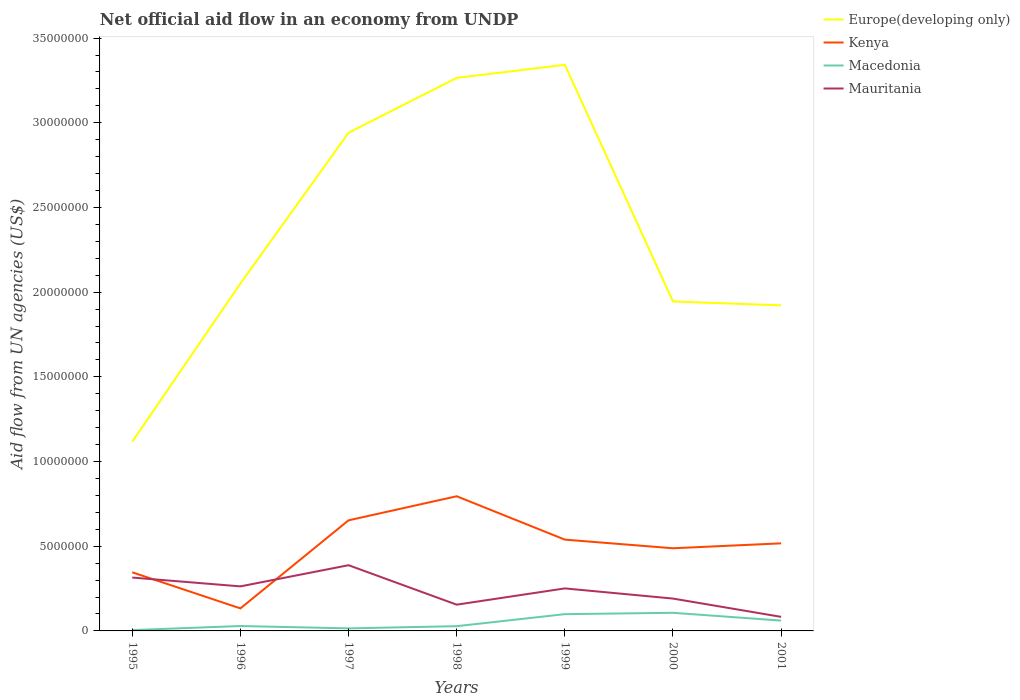How many different coloured lines are there?
Offer a terse response. 4. Does the line corresponding to Kenya intersect with the line corresponding to Europe(developing only)?
Keep it short and to the point. No. Is the number of lines equal to the number of legend labels?
Ensure brevity in your answer.  Yes. Across all years, what is the maximum net official aid flow in Mauritania?
Give a very brief answer. 8.30e+05. What is the total net official aid flow in Macedonia in the graph?
Provide a succinct answer. -2.40e+05. What is the difference between the highest and the second highest net official aid flow in Europe(developing only)?
Make the answer very short. 2.22e+07. What is the difference between the highest and the lowest net official aid flow in Macedonia?
Offer a very short reply. 3. Is the net official aid flow in Macedonia strictly greater than the net official aid flow in Mauritania over the years?
Offer a terse response. Yes. How many lines are there?
Keep it short and to the point. 4. What is the difference between two consecutive major ticks on the Y-axis?
Your answer should be very brief. 5.00e+06. How many legend labels are there?
Your answer should be very brief. 4. How are the legend labels stacked?
Provide a short and direct response. Vertical. What is the title of the graph?
Make the answer very short. Net official aid flow in an economy from UNDP. Does "Denmark" appear as one of the legend labels in the graph?
Make the answer very short. No. What is the label or title of the X-axis?
Your answer should be compact. Years. What is the label or title of the Y-axis?
Ensure brevity in your answer.  Aid flow from UN agencies (US$). What is the Aid flow from UN agencies (US$) in Europe(developing only) in 1995?
Your answer should be compact. 1.12e+07. What is the Aid flow from UN agencies (US$) of Kenya in 1995?
Offer a very short reply. 3.46e+06. What is the Aid flow from UN agencies (US$) in Mauritania in 1995?
Provide a succinct answer. 3.15e+06. What is the Aid flow from UN agencies (US$) of Europe(developing only) in 1996?
Give a very brief answer. 2.05e+07. What is the Aid flow from UN agencies (US$) in Kenya in 1996?
Give a very brief answer. 1.33e+06. What is the Aid flow from UN agencies (US$) in Macedonia in 1996?
Provide a short and direct response. 2.90e+05. What is the Aid flow from UN agencies (US$) in Mauritania in 1996?
Provide a succinct answer. 2.63e+06. What is the Aid flow from UN agencies (US$) of Europe(developing only) in 1997?
Your answer should be very brief. 2.94e+07. What is the Aid flow from UN agencies (US$) of Kenya in 1997?
Your answer should be compact. 6.53e+06. What is the Aid flow from UN agencies (US$) of Mauritania in 1997?
Provide a succinct answer. 3.88e+06. What is the Aid flow from UN agencies (US$) of Europe(developing only) in 1998?
Provide a short and direct response. 3.26e+07. What is the Aid flow from UN agencies (US$) in Kenya in 1998?
Provide a succinct answer. 7.95e+06. What is the Aid flow from UN agencies (US$) of Mauritania in 1998?
Keep it short and to the point. 1.55e+06. What is the Aid flow from UN agencies (US$) in Europe(developing only) in 1999?
Make the answer very short. 3.34e+07. What is the Aid flow from UN agencies (US$) in Kenya in 1999?
Provide a short and direct response. 5.39e+06. What is the Aid flow from UN agencies (US$) in Macedonia in 1999?
Offer a very short reply. 9.90e+05. What is the Aid flow from UN agencies (US$) of Mauritania in 1999?
Provide a short and direct response. 2.51e+06. What is the Aid flow from UN agencies (US$) of Europe(developing only) in 2000?
Give a very brief answer. 1.94e+07. What is the Aid flow from UN agencies (US$) in Kenya in 2000?
Make the answer very short. 4.88e+06. What is the Aid flow from UN agencies (US$) of Macedonia in 2000?
Your response must be concise. 1.07e+06. What is the Aid flow from UN agencies (US$) in Mauritania in 2000?
Your answer should be compact. 1.91e+06. What is the Aid flow from UN agencies (US$) in Europe(developing only) in 2001?
Your response must be concise. 1.92e+07. What is the Aid flow from UN agencies (US$) in Kenya in 2001?
Give a very brief answer. 5.17e+06. What is the Aid flow from UN agencies (US$) of Macedonia in 2001?
Provide a short and direct response. 6.10e+05. What is the Aid flow from UN agencies (US$) of Mauritania in 2001?
Your answer should be very brief. 8.30e+05. Across all years, what is the maximum Aid flow from UN agencies (US$) of Europe(developing only)?
Offer a very short reply. 3.34e+07. Across all years, what is the maximum Aid flow from UN agencies (US$) in Kenya?
Your response must be concise. 7.95e+06. Across all years, what is the maximum Aid flow from UN agencies (US$) in Macedonia?
Provide a short and direct response. 1.07e+06. Across all years, what is the maximum Aid flow from UN agencies (US$) of Mauritania?
Provide a short and direct response. 3.88e+06. Across all years, what is the minimum Aid flow from UN agencies (US$) of Europe(developing only)?
Offer a very short reply. 1.12e+07. Across all years, what is the minimum Aid flow from UN agencies (US$) of Kenya?
Give a very brief answer. 1.33e+06. Across all years, what is the minimum Aid flow from UN agencies (US$) of Macedonia?
Offer a terse response. 5.00e+04. Across all years, what is the minimum Aid flow from UN agencies (US$) in Mauritania?
Provide a short and direct response. 8.30e+05. What is the total Aid flow from UN agencies (US$) of Europe(developing only) in the graph?
Offer a terse response. 1.66e+08. What is the total Aid flow from UN agencies (US$) of Kenya in the graph?
Your answer should be very brief. 3.47e+07. What is the total Aid flow from UN agencies (US$) of Macedonia in the graph?
Offer a terse response. 3.44e+06. What is the total Aid flow from UN agencies (US$) in Mauritania in the graph?
Offer a terse response. 1.65e+07. What is the difference between the Aid flow from UN agencies (US$) of Europe(developing only) in 1995 and that in 1996?
Offer a very short reply. -9.34e+06. What is the difference between the Aid flow from UN agencies (US$) in Kenya in 1995 and that in 1996?
Your answer should be compact. 2.13e+06. What is the difference between the Aid flow from UN agencies (US$) in Mauritania in 1995 and that in 1996?
Provide a short and direct response. 5.20e+05. What is the difference between the Aid flow from UN agencies (US$) in Europe(developing only) in 1995 and that in 1997?
Ensure brevity in your answer.  -1.82e+07. What is the difference between the Aid flow from UN agencies (US$) in Kenya in 1995 and that in 1997?
Your response must be concise. -3.07e+06. What is the difference between the Aid flow from UN agencies (US$) of Macedonia in 1995 and that in 1997?
Ensure brevity in your answer.  -1.00e+05. What is the difference between the Aid flow from UN agencies (US$) in Mauritania in 1995 and that in 1997?
Offer a very short reply. -7.30e+05. What is the difference between the Aid flow from UN agencies (US$) in Europe(developing only) in 1995 and that in 1998?
Make the answer very short. -2.15e+07. What is the difference between the Aid flow from UN agencies (US$) of Kenya in 1995 and that in 1998?
Provide a short and direct response. -4.49e+06. What is the difference between the Aid flow from UN agencies (US$) of Macedonia in 1995 and that in 1998?
Provide a succinct answer. -2.30e+05. What is the difference between the Aid flow from UN agencies (US$) in Mauritania in 1995 and that in 1998?
Ensure brevity in your answer.  1.60e+06. What is the difference between the Aid flow from UN agencies (US$) of Europe(developing only) in 1995 and that in 1999?
Your response must be concise. -2.22e+07. What is the difference between the Aid flow from UN agencies (US$) of Kenya in 1995 and that in 1999?
Provide a succinct answer. -1.93e+06. What is the difference between the Aid flow from UN agencies (US$) of Macedonia in 1995 and that in 1999?
Provide a succinct answer. -9.40e+05. What is the difference between the Aid flow from UN agencies (US$) of Mauritania in 1995 and that in 1999?
Offer a very short reply. 6.40e+05. What is the difference between the Aid flow from UN agencies (US$) in Europe(developing only) in 1995 and that in 2000?
Your response must be concise. -8.28e+06. What is the difference between the Aid flow from UN agencies (US$) of Kenya in 1995 and that in 2000?
Make the answer very short. -1.42e+06. What is the difference between the Aid flow from UN agencies (US$) of Macedonia in 1995 and that in 2000?
Give a very brief answer. -1.02e+06. What is the difference between the Aid flow from UN agencies (US$) in Mauritania in 1995 and that in 2000?
Offer a terse response. 1.24e+06. What is the difference between the Aid flow from UN agencies (US$) of Europe(developing only) in 1995 and that in 2001?
Provide a succinct answer. -8.05e+06. What is the difference between the Aid flow from UN agencies (US$) of Kenya in 1995 and that in 2001?
Keep it short and to the point. -1.71e+06. What is the difference between the Aid flow from UN agencies (US$) of Macedonia in 1995 and that in 2001?
Provide a short and direct response. -5.60e+05. What is the difference between the Aid flow from UN agencies (US$) of Mauritania in 1995 and that in 2001?
Ensure brevity in your answer.  2.32e+06. What is the difference between the Aid flow from UN agencies (US$) in Europe(developing only) in 1996 and that in 1997?
Give a very brief answer. -8.90e+06. What is the difference between the Aid flow from UN agencies (US$) in Kenya in 1996 and that in 1997?
Your response must be concise. -5.20e+06. What is the difference between the Aid flow from UN agencies (US$) of Macedonia in 1996 and that in 1997?
Offer a terse response. 1.40e+05. What is the difference between the Aid flow from UN agencies (US$) in Mauritania in 1996 and that in 1997?
Your response must be concise. -1.25e+06. What is the difference between the Aid flow from UN agencies (US$) of Europe(developing only) in 1996 and that in 1998?
Your response must be concise. -1.21e+07. What is the difference between the Aid flow from UN agencies (US$) of Kenya in 1996 and that in 1998?
Give a very brief answer. -6.62e+06. What is the difference between the Aid flow from UN agencies (US$) of Macedonia in 1996 and that in 1998?
Ensure brevity in your answer.  10000. What is the difference between the Aid flow from UN agencies (US$) of Mauritania in 1996 and that in 1998?
Offer a terse response. 1.08e+06. What is the difference between the Aid flow from UN agencies (US$) in Europe(developing only) in 1996 and that in 1999?
Your response must be concise. -1.29e+07. What is the difference between the Aid flow from UN agencies (US$) in Kenya in 1996 and that in 1999?
Your answer should be compact. -4.06e+06. What is the difference between the Aid flow from UN agencies (US$) in Macedonia in 1996 and that in 1999?
Give a very brief answer. -7.00e+05. What is the difference between the Aid flow from UN agencies (US$) of Europe(developing only) in 1996 and that in 2000?
Keep it short and to the point. 1.06e+06. What is the difference between the Aid flow from UN agencies (US$) in Kenya in 1996 and that in 2000?
Keep it short and to the point. -3.55e+06. What is the difference between the Aid flow from UN agencies (US$) in Macedonia in 1996 and that in 2000?
Offer a very short reply. -7.80e+05. What is the difference between the Aid flow from UN agencies (US$) of Mauritania in 1996 and that in 2000?
Keep it short and to the point. 7.20e+05. What is the difference between the Aid flow from UN agencies (US$) in Europe(developing only) in 1996 and that in 2001?
Offer a very short reply. 1.29e+06. What is the difference between the Aid flow from UN agencies (US$) in Kenya in 1996 and that in 2001?
Offer a very short reply. -3.84e+06. What is the difference between the Aid flow from UN agencies (US$) of Macedonia in 1996 and that in 2001?
Make the answer very short. -3.20e+05. What is the difference between the Aid flow from UN agencies (US$) in Mauritania in 1996 and that in 2001?
Keep it short and to the point. 1.80e+06. What is the difference between the Aid flow from UN agencies (US$) of Europe(developing only) in 1997 and that in 1998?
Give a very brief answer. -3.24e+06. What is the difference between the Aid flow from UN agencies (US$) of Kenya in 1997 and that in 1998?
Keep it short and to the point. -1.42e+06. What is the difference between the Aid flow from UN agencies (US$) of Mauritania in 1997 and that in 1998?
Your answer should be very brief. 2.33e+06. What is the difference between the Aid flow from UN agencies (US$) of Europe(developing only) in 1997 and that in 1999?
Your response must be concise. -4.01e+06. What is the difference between the Aid flow from UN agencies (US$) of Kenya in 1997 and that in 1999?
Provide a succinct answer. 1.14e+06. What is the difference between the Aid flow from UN agencies (US$) of Macedonia in 1997 and that in 1999?
Provide a succinct answer. -8.40e+05. What is the difference between the Aid flow from UN agencies (US$) of Mauritania in 1997 and that in 1999?
Ensure brevity in your answer.  1.37e+06. What is the difference between the Aid flow from UN agencies (US$) of Europe(developing only) in 1997 and that in 2000?
Your response must be concise. 9.96e+06. What is the difference between the Aid flow from UN agencies (US$) of Kenya in 1997 and that in 2000?
Make the answer very short. 1.65e+06. What is the difference between the Aid flow from UN agencies (US$) of Macedonia in 1997 and that in 2000?
Provide a short and direct response. -9.20e+05. What is the difference between the Aid flow from UN agencies (US$) of Mauritania in 1997 and that in 2000?
Your answer should be compact. 1.97e+06. What is the difference between the Aid flow from UN agencies (US$) in Europe(developing only) in 1997 and that in 2001?
Your response must be concise. 1.02e+07. What is the difference between the Aid flow from UN agencies (US$) of Kenya in 1997 and that in 2001?
Your response must be concise. 1.36e+06. What is the difference between the Aid flow from UN agencies (US$) in Macedonia in 1997 and that in 2001?
Your response must be concise. -4.60e+05. What is the difference between the Aid flow from UN agencies (US$) in Mauritania in 1997 and that in 2001?
Offer a very short reply. 3.05e+06. What is the difference between the Aid flow from UN agencies (US$) of Europe(developing only) in 1998 and that in 1999?
Offer a terse response. -7.70e+05. What is the difference between the Aid flow from UN agencies (US$) in Kenya in 1998 and that in 1999?
Your answer should be compact. 2.56e+06. What is the difference between the Aid flow from UN agencies (US$) of Macedonia in 1998 and that in 1999?
Keep it short and to the point. -7.10e+05. What is the difference between the Aid flow from UN agencies (US$) of Mauritania in 1998 and that in 1999?
Keep it short and to the point. -9.60e+05. What is the difference between the Aid flow from UN agencies (US$) in Europe(developing only) in 1998 and that in 2000?
Give a very brief answer. 1.32e+07. What is the difference between the Aid flow from UN agencies (US$) in Kenya in 1998 and that in 2000?
Offer a terse response. 3.07e+06. What is the difference between the Aid flow from UN agencies (US$) in Macedonia in 1998 and that in 2000?
Give a very brief answer. -7.90e+05. What is the difference between the Aid flow from UN agencies (US$) of Mauritania in 1998 and that in 2000?
Your answer should be compact. -3.60e+05. What is the difference between the Aid flow from UN agencies (US$) of Europe(developing only) in 1998 and that in 2001?
Provide a succinct answer. 1.34e+07. What is the difference between the Aid flow from UN agencies (US$) in Kenya in 1998 and that in 2001?
Give a very brief answer. 2.78e+06. What is the difference between the Aid flow from UN agencies (US$) in Macedonia in 1998 and that in 2001?
Give a very brief answer. -3.30e+05. What is the difference between the Aid flow from UN agencies (US$) of Mauritania in 1998 and that in 2001?
Make the answer very short. 7.20e+05. What is the difference between the Aid flow from UN agencies (US$) in Europe(developing only) in 1999 and that in 2000?
Offer a very short reply. 1.40e+07. What is the difference between the Aid flow from UN agencies (US$) in Kenya in 1999 and that in 2000?
Your answer should be very brief. 5.10e+05. What is the difference between the Aid flow from UN agencies (US$) of Macedonia in 1999 and that in 2000?
Your answer should be very brief. -8.00e+04. What is the difference between the Aid flow from UN agencies (US$) in Mauritania in 1999 and that in 2000?
Your answer should be very brief. 6.00e+05. What is the difference between the Aid flow from UN agencies (US$) of Europe(developing only) in 1999 and that in 2001?
Provide a short and direct response. 1.42e+07. What is the difference between the Aid flow from UN agencies (US$) in Kenya in 1999 and that in 2001?
Keep it short and to the point. 2.20e+05. What is the difference between the Aid flow from UN agencies (US$) in Mauritania in 1999 and that in 2001?
Make the answer very short. 1.68e+06. What is the difference between the Aid flow from UN agencies (US$) in Europe(developing only) in 2000 and that in 2001?
Provide a short and direct response. 2.30e+05. What is the difference between the Aid flow from UN agencies (US$) in Mauritania in 2000 and that in 2001?
Your response must be concise. 1.08e+06. What is the difference between the Aid flow from UN agencies (US$) in Europe(developing only) in 1995 and the Aid flow from UN agencies (US$) in Kenya in 1996?
Provide a succinct answer. 9.84e+06. What is the difference between the Aid flow from UN agencies (US$) in Europe(developing only) in 1995 and the Aid flow from UN agencies (US$) in Macedonia in 1996?
Offer a terse response. 1.09e+07. What is the difference between the Aid flow from UN agencies (US$) in Europe(developing only) in 1995 and the Aid flow from UN agencies (US$) in Mauritania in 1996?
Offer a terse response. 8.54e+06. What is the difference between the Aid flow from UN agencies (US$) of Kenya in 1995 and the Aid flow from UN agencies (US$) of Macedonia in 1996?
Your answer should be very brief. 3.17e+06. What is the difference between the Aid flow from UN agencies (US$) in Kenya in 1995 and the Aid flow from UN agencies (US$) in Mauritania in 1996?
Give a very brief answer. 8.30e+05. What is the difference between the Aid flow from UN agencies (US$) in Macedonia in 1995 and the Aid flow from UN agencies (US$) in Mauritania in 1996?
Your response must be concise. -2.58e+06. What is the difference between the Aid flow from UN agencies (US$) of Europe(developing only) in 1995 and the Aid flow from UN agencies (US$) of Kenya in 1997?
Make the answer very short. 4.64e+06. What is the difference between the Aid flow from UN agencies (US$) in Europe(developing only) in 1995 and the Aid flow from UN agencies (US$) in Macedonia in 1997?
Your response must be concise. 1.10e+07. What is the difference between the Aid flow from UN agencies (US$) in Europe(developing only) in 1995 and the Aid flow from UN agencies (US$) in Mauritania in 1997?
Make the answer very short. 7.29e+06. What is the difference between the Aid flow from UN agencies (US$) in Kenya in 1995 and the Aid flow from UN agencies (US$) in Macedonia in 1997?
Make the answer very short. 3.31e+06. What is the difference between the Aid flow from UN agencies (US$) of Kenya in 1995 and the Aid flow from UN agencies (US$) of Mauritania in 1997?
Provide a short and direct response. -4.20e+05. What is the difference between the Aid flow from UN agencies (US$) of Macedonia in 1995 and the Aid flow from UN agencies (US$) of Mauritania in 1997?
Your response must be concise. -3.83e+06. What is the difference between the Aid flow from UN agencies (US$) of Europe(developing only) in 1995 and the Aid flow from UN agencies (US$) of Kenya in 1998?
Offer a terse response. 3.22e+06. What is the difference between the Aid flow from UN agencies (US$) in Europe(developing only) in 1995 and the Aid flow from UN agencies (US$) in Macedonia in 1998?
Keep it short and to the point. 1.09e+07. What is the difference between the Aid flow from UN agencies (US$) of Europe(developing only) in 1995 and the Aid flow from UN agencies (US$) of Mauritania in 1998?
Your answer should be very brief. 9.62e+06. What is the difference between the Aid flow from UN agencies (US$) of Kenya in 1995 and the Aid flow from UN agencies (US$) of Macedonia in 1998?
Your answer should be very brief. 3.18e+06. What is the difference between the Aid flow from UN agencies (US$) of Kenya in 1995 and the Aid flow from UN agencies (US$) of Mauritania in 1998?
Your response must be concise. 1.91e+06. What is the difference between the Aid flow from UN agencies (US$) in Macedonia in 1995 and the Aid flow from UN agencies (US$) in Mauritania in 1998?
Give a very brief answer. -1.50e+06. What is the difference between the Aid flow from UN agencies (US$) of Europe(developing only) in 1995 and the Aid flow from UN agencies (US$) of Kenya in 1999?
Offer a very short reply. 5.78e+06. What is the difference between the Aid flow from UN agencies (US$) of Europe(developing only) in 1995 and the Aid flow from UN agencies (US$) of Macedonia in 1999?
Your response must be concise. 1.02e+07. What is the difference between the Aid flow from UN agencies (US$) in Europe(developing only) in 1995 and the Aid flow from UN agencies (US$) in Mauritania in 1999?
Offer a terse response. 8.66e+06. What is the difference between the Aid flow from UN agencies (US$) in Kenya in 1995 and the Aid flow from UN agencies (US$) in Macedonia in 1999?
Give a very brief answer. 2.47e+06. What is the difference between the Aid flow from UN agencies (US$) in Kenya in 1995 and the Aid flow from UN agencies (US$) in Mauritania in 1999?
Offer a very short reply. 9.50e+05. What is the difference between the Aid flow from UN agencies (US$) in Macedonia in 1995 and the Aid flow from UN agencies (US$) in Mauritania in 1999?
Your response must be concise. -2.46e+06. What is the difference between the Aid flow from UN agencies (US$) in Europe(developing only) in 1995 and the Aid flow from UN agencies (US$) in Kenya in 2000?
Your answer should be compact. 6.29e+06. What is the difference between the Aid flow from UN agencies (US$) in Europe(developing only) in 1995 and the Aid flow from UN agencies (US$) in Macedonia in 2000?
Your answer should be very brief. 1.01e+07. What is the difference between the Aid flow from UN agencies (US$) in Europe(developing only) in 1995 and the Aid flow from UN agencies (US$) in Mauritania in 2000?
Your answer should be compact. 9.26e+06. What is the difference between the Aid flow from UN agencies (US$) of Kenya in 1995 and the Aid flow from UN agencies (US$) of Macedonia in 2000?
Make the answer very short. 2.39e+06. What is the difference between the Aid flow from UN agencies (US$) in Kenya in 1995 and the Aid flow from UN agencies (US$) in Mauritania in 2000?
Give a very brief answer. 1.55e+06. What is the difference between the Aid flow from UN agencies (US$) of Macedonia in 1995 and the Aid flow from UN agencies (US$) of Mauritania in 2000?
Your answer should be very brief. -1.86e+06. What is the difference between the Aid flow from UN agencies (US$) of Europe(developing only) in 1995 and the Aid flow from UN agencies (US$) of Macedonia in 2001?
Provide a short and direct response. 1.06e+07. What is the difference between the Aid flow from UN agencies (US$) of Europe(developing only) in 1995 and the Aid flow from UN agencies (US$) of Mauritania in 2001?
Keep it short and to the point. 1.03e+07. What is the difference between the Aid flow from UN agencies (US$) of Kenya in 1995 and the Aid flow from UN agencies (US$) of Macedonia in 2001?
Provide a succinct answer. 2.85e+06. What is the difference between the Aid flow from UN agencies (US$) in Kenya in 1995 and the Aid flow from UN agencies (US$) in Mauritania in 2001?
Provide a short and direct response. 2.63e+06. What is the difference between the Aid flow from UN agencies (US$) in Macedonia in 1995 and the Aid flow from UN agencies (US$) in Mauritania in 2001?
Your answer should be very brief. -7.80e+05. What is the difference between the Aid flow from UN agencies (US$) of Europe(developing only) in 1996 and the Aid flow from UN agencies (US$) of Kenya in 1997?
Your response must be concise. 1.40e+07. What is the difference between the Aid flow from UN agencies (US$) in Europe(developing only) in 1996 and the Aid flow from UN agencies (US$) in Macedonia in 1997?
Your answer should be very brief. 2.04e+07. What is the difference between the Aid flow from UN agencies (US$) in Europe(developing only) in 1996 and the Aid flow from UN agencies (US$) in Mauritania in 1997?
Offer a terse response. 1.66e+07. What is the difference between the Aid flow from UN agencies (US$) of Kenya in 1996 and the Aid flow from UN agencies (US$) of Macedonia in 1997?
Offer a terse response. 1.18e+06. What is the difference between the Aid flow from UN agencies (US$) of Kenya in 1996 and the Aid flow from UN agencies (US$) of Mauritania in 1997?
Provide a succinct answer. -2.55e+06. What is the difference between the Aid flow from UN agencies (US$) in Macedonia in 1996 and the Aid flow from UN agencies (US$) in Mauritania in 1997?
Your answer should be compact. -3.59e+06. What is the difference between the Aid flow from UN agencies (US$) of Europe(developing only) in 1996 and the Aid flow from UN agencies (US$) of Kenya in 1998?
Your answer should be compact. 1.26e+07. What is the difference between the Aid flow from UN agencies (US$) of Europe(developing only) in 1996 and the Aid flow from UN agencies (US$) of Macedonia in 1998?
Offer a terse response. 2.02e+07. What is the difference between the Aid flow from UN agencies (US$) of Europe(developing only) in 1996 and the Aid flow from UN agencies (US$) of Mauritania in 1998?
Provide a succinct answer. 1.90e+07. What is the difference between the Aid flow from UN agencies (US$) of Kenya in 1996 and the Aid flow from UN agencies (US$) of Macedonia in 1998?
Ensure brevity in your answer.  1.05e+06. What is the difference between the Aid flow from UN agencies (US$) in Macedonia in 1996 and the Aid flow from UN agencies (US$) in Mauritania in 1998?
Provide a short and direct response. -1.26e+06. What is the difference between the Aid flow from UN agencies (US$) in Europe(developing only) in 1996 and the Aid flow from UN agencies (US$) in Kenya in 1999?
Your answer should be very brief. 1.51e+07. What is the difference between the Aid flow from UN agencies (US$) in Europe(developing only) in 1996 and the Aid flow from UN agencies (US$) in Macedonia in 1999?
Provide a succinct answer. 1.95e+07. What is the difference between the Aid flow from UN agencies (US$) in Europe(developing only) in 1996 and the Aid flow from UN agencies (US$) in Mauritania in 1999?
Make the answer very short. 1.80e+07. What is the difference between the Aid flow from UN agencies (US$) of Kenya in 1996 and the Aid flow from UN agencies (US$) of Mauritania in 1999?
Make the answer very short. -1.18e+06. What is the difference between the Aid flow from UN agencies (US$) of Macedonia in 1996 and the Aid flow from UN agencies (US$) of Mauritania in 1999?
Provide a short and direct response. -2.22e+06. What is the difference between the Aid flow from UN agencies (US$) of Europe(developing only) in 1996 and the Aid flow from UN agencies (US$) of Kenya in 2000?
Ensure brevity in your answer.  1.56e+07. What is the difference between the Aid flow from UN agencies (US$) of Europe(developing only) in 1996 and the Aid flow from UN agencies (US$) of Macedonia in 2000?
Make the answer very short. 1.94e+07. What is the difference between the Aid flow from UN agencies (US$) of Europe(developing only) in 1996 and the Aid flow from UN agencies (US$) of Mauritania in 2000?
Your answer should be compact. 1.86e+07. What is the difference between the Aid flow from UN agencies (US$) of Kenya in 1996 and the Aid flow from UN agencies (US$) of Macedonia in 2000?
Offer a terse response. 2.60e+05. What is the difference between the Aid flow from UN agencies (US$) of Kenya in 1996 and the Aid flow from UN agencies (US$) of Mauritania in 2000?
Provide a succinct answer. -5.80e+05. What is the difference between the Aid flow from UN agencies (US$) of Macedonia in 1996 and the Aid flow from UN agencies (US$) of Mauritania in 2000?
Provide a short and direct response. -1.62e+06. What is the difference between the Aid flow from UN agencies (US$) of Europe(developing only) in 1996 and the Aid flow from UN agencies (US$) of Kenya in 2001?
Provide a short and direct response. 1.53e+07. What is the difference between the Aid flow from UN agencies (US$) in Europe(developing only) in 1996 and the Aid flow from UN agencies (US$) in Macedonia in 2001?
Your answer should be compact. 1.99e+07. What is the difference between the Aid flow from UN agencies (US$) of Europe(developing only) in 1996 and the Aid flow from UN agencies (US$) of Mauritania in 2001?
Your answer should be compact. 1.97e+07. What is the difference between the Aid flow from UN agencies (US$) in Kenya in 1996 and the Aid flow from UN agencies (US$) in Macedonia in 2001?
Your response must be concise. 7.20e+05. What is the difference between the Aid flow from UN agencies (US$) of Kenya in 1996 and the Aid flow from UN agencies (US$) of Mauritania in 2001?
Provide a short and direct response. 5.00e+05. What is the difference between the Aid flow from UN agencies (US$) of Macedonia in 1996 and the Aid flow from UN agencies (US$) of Mauritania in 2001?
Offer a terse response. -5.40e+05. What is the difference between the Aid flow from UN agencies (US$) in Europe(developing only) in 1997 and the Aid flow from UN agencies (US$) in Kenya in 1998?
Offer a very short reply. 2.15e+07. What is the difference between the Aid flow from UN agencies (US$) in Europe(developing only) in 1997 and the Aid flow from UN agencies (US$) in Macedonia in 1998?
Give a very brief answer. 2.91e+07. What is the difference between the Aid flow from UN agencies (US$) in Europe(developing only) in 1997 and the Aid flow from UN agencies (US$) in Mauritania in 1998?
Your answer should be very brief. 2.79e+07. What is the difference between the Aid flow from UN agencies (US$) in Kenya in 1997 and the Aid flow from UN agencies (US$) in Macedonia in 1998?
Offer a very short reply. 6.25e+06. What is the difference between the Aid flow from UN agencies (US$) in Kenya in 1997 and the Aid flow from UN agencies (US$) in Mauritania in 1998?
Offer a terse response. 4.98e+06. What is the difference between the Aid flow from UN agencies (US$) of Macedonia in 1997 and the Aid flow from UN agencies (US$) of Mauritania in 1998?
Make the answer very short. -1.40e+06. What is the difference between the Aid flow from UN agencies (US$) in Europe(developing only) in 1997 and the Aid flow from UN agencies (US$) in Kenya in 1999?
Offer a very short reply. 2.40e+07. What is the difference between the Aid flow from UN agencies (US$) of Europe(developing only) in 1997 and the Aid flow from UN agencies (US$) of Macedonia in 1999?
Make the answer very short. 2.84e+07. What is the difference between the Aid flow from UN agencies (US$) in Europe(developing only) in 1997 and the Aid flow from UN agencies (US$) in Mauritania in 1999?
Provide a short and direct response. 2.69e+07. What is the difference between the Aid flow from UN agencies (US$) of Kenya in 1997 and the Aid flow from UN agencies (US$) of Macedonia in 1999?
Provide a short and direct response. 5.54e+06. What is the difference between the Aid flow from UN agencies (US$) in Kenya in 1997 and the Aid flow from UN agencies (US$) in Mauritania in 1999?
Keep it short and to the point. 4.02e+06. What is the difference between the Aid flow from UN agencies (US$) of Macedonia in 1997 and the Aid flow from UN agencies (US$) of Mauritania in 1999?
Your response must be concise. -2.36e+06. What is the difference between the Aid flow from UN agencies (US$) in Europe(developing only) in 1997 and the Aid flow from UN agencies (US$) in Kenya in 2000?
Your answer should be very brief. 2.45e+07. What is the difference between the Aid flow from UN agencies (US$) of Europe(developing only) in 1997 and the Aid flow from UN agencies (US$) of Macedonia in 2000?
Your response must be concise. 2.83e+07. What is the difference between the Aid flow from UN agencies (US$) in Europe(developing only) in 1997 and the Aid flow from UN agencies (US$) in Mauritania in 2000?
Your answer should be very brief. 2.75e+07. What is the difference between the Aid flow from UN agencies (US$) of Kenya in 1997 and the Aid flow from UN agencies (US$) of Macedonia in 2000?
Give a very brief answer. 5.46e+06. What is the difference between the Aid flow from UN agencies (US$) in Kenya in 1997 and the Aid flow from UN agencies (US$) in Mauritania in 2000?
Make the answer very short. 4.62e+06. What is the difference between the Aid flow from UN agencies (US$) in Macedonia in 1997 and the Aid flow from UN agencies (US$) in Mauritania in 2000?
Offer a terse response. -1.76e+06. What is the difference between the Aid flow from UN agencies (US$) of Europe(developing only) in 1997 and the Aid flow from UN agencies (US$) of Kenya in 2001?
Offer a very short reply. 2.42e+07. What is the difference between the Aid flow from UN agencies (US$) in Europe(developing only) in 1997 and the Aid flow from UN agencies (US$) in Macedonia in 2001?
Offer a very short reply. 2.88e+07. What is the difference between the Aid flow from UN agencies (US$) in Europe(developing only) in 1997 and the Aid flow from UN agencies (US$) in Mauritania in 2001?
Offer a very short reply. 2.86e+07. What is the difference between the Aid flow from UN agencies (US$) in Kenya in 1997 and the Aid flow from UN agencies (US$) in Macedonia in 2001?
Provide a succinct answer. 5.92e+06. What is the difference between the Aid flow from UN agencies (US$) in Kenya in 1997 and the Aid flow from UN agencies (US$) in Mauritania in 2001?
Your answer should be compact. 5.70e+06. What is the difference between the Aid flow from UN agencies (US$) of Macedonia in 1997 and the Aid flow from UN agencies (US$) of Mauritania in 2001?
Offer a very short reply. -6.80e+05. What is the difference between the Aid flow from UN agencies (US$) of Europe(developing only) in 1998 and the Aid flow from UN agencies (US$) of Kenya in 1999?
Offer a very short reply. 2.73e+07. What is the difference between the Aid flow from UN agencies (US$) of Europe(developing only) in 1998 and the Aid flow from UN agencies (US$) of Macedonia in 1999?
Ensure brevity in your answer.  3.17e+07. What is the difference between the Aid flow from UN agencies (US$) in Europe(developing only) in 1998 and the Aid flow from UN agencies (US$) in Mauritania in 1999?
Your answer should be compact. 3.01e+07. What is the difference between the Aid flow from UN agencies (US$) of Kenya in 1998 and the Aid flow from UN agencies (US$) of Macedonia in 1999?
Your answer should be compact. 6.96e+06. What is the difference between the Aid flow from UN agencies (US$) of Kenya in 1998 and the Aid flow from UN agencies (US$) of Mauritania in 1999?
Give a very brief answer. 5.44e+06. What is the difference between the Aid flow from UN agencies (US$) in Macedonia in 1998 and the Aid flow from UN agencies (US$) in Mauritania in 1999?
Your answer should be compact. -2.23e+06. What is the difference between the Aid flow from UN agencies (US$) in Europe(developing only) in 1998 and the Aid flow from UN agencies (US$) in Kenya in 2000?
Provide a short and direct response. 2.78e+07. What is the difference between the Aid flow from UN agencies (US$) of Europe(developing only) in 1998 and the Aid flow from UN agencies (US$) of Macedonia in 2000?
Offer a terse response. 3.16e+07. What is the difference between the Aid flow from UN agencies (US$) in Europe(developing only) in 1998 and the Aid flow from UN agencies (US$) in Mauritania in 2000?
Give a very brief answer. 3.07e+07. What is the difference between the Aid flow from UN agencies (US$) in Kenya in 1998 and the Aid flow from UN agencies (US$) in Macedonia in 2000?
Your answer should be compact. 6.88e+06. What is the difference between the Aid flow from UN agencies (US$) in Kenya in 1998 and the Aid flow from UN agencies (US$) in Mauritania in 2000?
Your answer should be compact. 6.04e+06. What is the difference between the Aid flow from UN agencies (US$) of Macedonia in 1998 and the Aid flow from UN agencies (US$) of Mauritania in 2000?
Offer a very short reply. -1.63e+06. What is the difference between the Aid flow from UN agencies (US$) of Europe(developing only) in 1998 and the Aid flow from UN agencies (US$) of Kenya in 2001?
Provide a short and direct response. 2.75e+07. What is the difference between the Aid flow from UN agencies (US$) of Europe(developing only) in 1998 and the Aid flow from UN agencies (US$) of Macedonia in 2001?
Keep it short and to the point. 3.20e+07. What is the difference between the Aid flow from UN agencies (US$) of Europe(developing only) in 1998 and the Aid flow from UN agencies (US$) of Mauritania in 2001?
Give a very brief answer. 3.18e+07. What is the difference between the Aid flow from UN agencies (US$) in Kenya in 1998 and the Aid flow from UN agencies (US$) in Macedonia in 2001?
Offer a very short reply. 7.34e+06. What is the difference between the Aid flow from UN agencies (US$) of Kenya in 1998 and the Aid flow from UN agencies (US$) of Mauritania in 2001?
Your response must be concise. 7.12e+06. What is the difference between the Aid flow from UN agencies (US$) in Macedonia in 1998 and the Aid flow from UN agencies (US$) in Mauritania in 2001?
Make the answer very short. -5.50e+05. What is the difference between the Aid flow from UN agencies (US$) of Europe(developing only) in 1999 and the Aid flow from UN agencies (US$) of Kenya in 2000?
Offer a very short reply. 2.85e+07. What is the difference between the Aid flow from UN agencies (US$) of Europe(developing only) in 1999 and the Aid flow from UN agencies (US$) of Macedonia in 2000?
Keep it short and to the point. 3.24e+07. What is the difference between the Aid flow from UN agencies (US$) of Europe(developing only) in 1999 and the Aid flow from UN agencies (US$) of Mauritania in 2000?
Your response must be concise. 3.15e+07. What is the difference between the Aid flow from UN agencies (US$) in Kenya in 1999 and the Aid flow from UN agencies (US$) in Macedonia in 2000?
Offer a very short reply. 4.32e+06. What is the difference between the Aid flow from UN agencies (US$) in Kenya in 1999 and the Aid flow from UN agencies (US$) in Mauritania in 2000?
Keep it short and to the point. 3.48e+06. What is the difference between the Aid flow from UN agencies (US$) of Macedonia in 1999 and the Aid flow from UN agencies (US$) of Mauritania in 2000?
Offer a terse response. -9.20e+05. What is the difference between the Aid flow from UN agencies (US$) of Europe(developing only) in 1999 and the Aid flow from UN agencies (US$) of Kenya in 2001?
Your answer should be compact. 2.82e+07. What is the difference between the Aid flow from UN agencies (US$) in Europe(developing only) in 1999 and the Aid flow from UN agencies (US$) in Macedonia in 2001?
Your answer should be compact. 3.28e+07. What is the difference between the Aid flow from UN agencies (US$) of Europe(developing only) in 1999 and the Aid flow from UN agencies (US$) of Mauritania in 2001?
Provide a succinct answer. 3.26e+07. What is the difference between the Aid flow from UN agencies (US$) of Kenya in 1999 and the Aid flow from UN agencies (US$) of Macedonia in 2001?
Offer a terse response. 4.78e+06. What is the difference between the Aid flow from UN agencies (US$) in Kenya in 1999 and the Aid flow from UN agencies (US$) in Mauritania in 2001?
Make the answer very short. 4.56e+06. What is the difference between the Aid flow from UN agencies (US$) of Macedonia in 1999 and the Aid flow from UN agencies (US$) of Mauritania in 2001?
Your answer should be compact. 1.60e+05. What is the difference between the Aid flow from UN agencies (US$) of Europe(developing only) in 2000 and the Aid flow from UN agencies (US$) of Kenya in 2001?
Your answer should be very brief. 1.43e+07. What is the difference between the Aid flow from UN agencies (US$) of Europe(developing only) in 2000 and the Aid flow from UN agencies (US$) of Macedonia in 2001?
Keep it short and to the point. 1.88e+07. What is the difference between the Aid flow from UN agencies (US$) in Europe(developing only) in 2000 and the Aid flow from UN agencies (US$) in Mauritania in 2001?
Your answer should be compact. 1.86e+07. What is the difference between the Aid flow from UN agencies (US$) of Kenya in 2000 and the Aid flow from UN agencies (US$) of Macedonia in 2001?
Your answer should be very brief. 4.27e+06. What is the difference between the Aid flow from UN agencies (US$) of Kenya in 2000 and the Aid flow from UN agencies (US$) of Mauritania in 2001?
Your response must be concise. 4.05e+06. What is the average Aid flow from UN agencies (US$) of Europe(developing only) per year?
Give a very brief answer. 2.37e+07. What is the average Aid flow from UN agencies (US$) in Kenya per year?
Provide a succinct answer. 4.96e+06. What is the average Aid flow from UN agencies (US$) of Macedonia per year?
Keep it short and to the point. 4.91e+05. What is the average Aid flow from UN agencies (US$) of Mauritania per year?
Give a very brief answer. 2.35e+06. In the year 1995, what is the difference between the Aid flow from UN agencies (US$) of Europe(developing only) and Aid flow from UN agencies (US$) of Kenya?
Ensure brevity in your answer.  7.71e+06. In the year 1995, what is the difference between the Aid flow from UN agencies (US$) in Europe(developing only) and Aid flow from UN agencies (US$) in Macedonia?
Provide a short and direct response. 1.11e+07. In the year 1995, what is the difference between the Aid flow from UN agencies (US$) of Europe(developing only) and Aid flow from UN agencies (US$) of Mauritania?
Provide a succinct answer. 8.02e+06. In the year 1995, what is the difference between the Aid flow from UN agencies (US$) of Kenya and Aid flow from UN agencies (US$) of Macedonia?
Offer a terse response. 3.41e+06. In the year 1995, what is the difference between the Aid flow from UN agencies (US$) of Kenya and Aid flow from UN agencies (US$) of Mauritania?
Your answer should be very brief. 3.10e+05. In the year 1995, what is the difference between the Aid flow from UN agencies (US$) of Macedonia and Aid flow from UN agencies (US$) of Mauritania?
Your answer should be very brief. -3.10e+06. In the year 1996, what is the difference between the Aid flow from UN agencies (US$) of Europe(developing only) and Aid flow from UN agencies (US$) of Kenya?
Your answer should be very brief. 1.92e+07. In the year 1996, what is the difference between the Aid flow from UN agencies (US$) of Europe(developing only) and Aid flow from UN agencies (US$) of Macedonia?
Offer a very short reply. 2.02e+07. In the year 1996, what is the difference between the Aid flow from UN agencies (US$) of Europe(developing only) and Aid flow from UN agencies (US$) of Mauritania?
Make the answer very short. 1.79e+07. In the year 1996, what is the difference between the Aid flow from UN agencies (US$) of Kenya and Aid flow from UN agencies (US$) of Macedonia?
Offer a terse response. 1.04e+06. In the year 1996, what is the difference between the Aid flow from UN agencies (US$) of Kenya and Aid flow from UN agencies (US$) of Mauritania?
Offer a very short reply. -1.30e+06. In the year 1996, what is the difference between the Aid flow from UN agencies (US$) of Macedonia and Aid flow from UN agencies (US$) of Mauritania?
Keep it short and to the point. -2.34e+06. In the year 1997, what is the difference between the Aid flow from UN agencies (US$) of Europe(developing only) and Aid flow from UN agencies (US$) of Kenya?
Provide a short and direct response. 2.29e+07. In the year 1997, what is the difference between the Aid flow from UN agencies (US$) of Europe(developing only) and Aid flow from UN agencies (US$) of Macedonia?
Keep it short and to the point. 2.93e+07. In the year 1997, what is the difference between the Aid flow from UN agencies (US$) of Europe(developing only) and Aid flow from UN agencies (US$) of Mauritania?
Offer a terse response. 2.55e+07. In the year 1997, what is the difference between the Aid flow from UN agencies (US$) in Kenya and Aid flow from UN agencies (US$) in Macedonia?
Provide a succinct answer. 6.38e+06. In the year 1997, what is the difference between the Aid flow from UN agencies (US$) of Kenya and Aid flow from UN agencies (US$) of Mauritania?
Give a very brief answer. 2.65e+06. In the year 1997, what is the difference between the Aid flow from UN agencies (US$) in Macedonia and Aid flow from UN agencies (US$) in Mauritania?
Your response must be concise. -3.73e+06. In the year 1998, what is the difference between the Aid flow from UN agencies (US$) in Europe(developing only) and Aid flow from UN agencies (US$) in Kenya?
Keep it short and to the point. 2.47e+07. In the year 1998, what is the difference between the Aid flow from UN agencies (US$) in Europe(developing only) and Aid flow from UN agencies (US$) in Macedonia?
Provide a succinct answer. 3.24e+07. In the year 1998, what is the difference between the Aid flow from UN agencies (US$) in Europe(developing only) and Aid flow from UN agencies (US$) in Mauritania?
Your response must be concise. 3.11e+07. In the year 1998, what is the difference between the Aid flow from UN agencies (US$) in Kenya and Aid flow from UN agencies (US$) in Macedonia?
Your response must be concise. 7.67e+06. In the year 1998, what is the difference between the Aid flow from UN agencies (US$) in Kenya and Aid flow from UN agencies (US$) in Mauritania?
Provide a short and direct response. 6.40e+06. In the year 1998, what is the difference between the Aid flow from UN agencies (US$) in Macedonia and Aid flow from UN agencies (US$) in Mauritania?
Your response must be concise. -1.27e+06. In the year 1999, what is the difference between the Aid flow from UN agencies (US$) of Europe(developing only) and Aid flow from UN agencies (US$) of Kenya?
Offer a terse response. 2.80e+07. In the year 1999, what is the difference between the Aid flow from UN agencies (US$) of Europe(developing only) and Aid flow from UN agencies (US$) of Macedonia?
Offer a terse response. 3.24e+07. In the year 1999, what is the difference between the Aid flow from UN agencies (US$) of Europe(developing only) and Aid flow from UN agencies (US$) of Mauritania?
Make the answer very short. 3.09e+07. In the year 1999, what is the difference between the Aid flow from UN agencies (US$) of Kenya and Aid flow from UN agencies (US$) of Macedonia?
Ensure brevity in your answer.  4.40e+06. In the year 1999, what is the difference between the Aid flow from UN agencies (US$) of Kenya and Aid flow from UN agencies (US$) of Mauritania?
Make the answer very short. 2.88e+06. In the year 1999, what is the difference between the Aid flow from UN agencies (US$) of Macedonia and Aid flow from UN agencies (US$) of Mauritania?
Keep it short and to the point. -1.52e+06. In the year 2000, what is the difference between the Aid flow from UN agencies (US$) in Europe(developing only) and Aid flow from UN agencies (US$) in Kenya?
Offer a terse response. 1.46e+07. In the year 2000, what is the difference between the Aid flow from UN agencies (US$) in Europe(developing only) and Aid flow from UN agencies (US$) in Macedonia?
Ensure brevity in your answer.  1.84e+07. In the year 2000, what is the difference between the Aid flow from UN agencies (US$) of Europe(developing only) and Aid flow from UN agencies (US$) of Mauritania?
Your answer should be compact. 1.75e+07. In the year 2000, what is the difference between the Aid flow from UN agencies (US$) of Kenya and Aid flow from UN agencies (US$) of Macedonia?
Your answer should be very brief. 3.81e+06. In the year 2000, what is the difference between the Aid flow from UN agencies (US$) in Kenya and Aid flow from UN agencies (US$) in Mauritania?
Your answer should be compact. 2.97e+06. In the year 2000, what is the difference between the Aid flow from UN agencies (US$) in Macedonia and Aid flow from UN agencies (US$) in Mauritania?
Your answer should be very brief. -8.40e+05. In the year 2001, what is the difference between the Aid flow from UN agencies (US$) of Europe(developing only) and Aid flow from UN agencies (US$) of Kenya?
Provide a succinct answer. 1.40e+07. In the year 2001, what is the difference between the Aid flow from UN agencies (US$) in Europe(developing only) and Aid flow from UN agencies (US$) in Macedonia?
Your answer should be compact. 1.86e+07. In the year 2001, what is the difference between the Aid flow from UN agencies (US$) in Europe(developing only) and Aid flow from UN agencies (US$) in Mauritania?
Make the answer very short. 1.84e+07. In the year 2001, what is the difference between the Aid flow from UN agencies (US$) in Kenya and Aid flow from UN agencies (US$) in Macedonia?
Give a very brief answer. 4.56e+06. In the year 2001, what is the difference between the Aid flow from UN agencies (US$) of Kenya and Aid flow from UN agencies (US$) of Mauritania?
Ensure brevity in your answer.  4.34e+06. In the year 2001, what is the difference between the Aid flow from UN agencies (US$) of Macedonia and Aid flow from UN agencies (US$) of Mauritania?
Provide a succinct answer. -2.20e+05. What is the ratio of the Aid flow from UN agencies (US$) in Europe(developing only) in 1995 to that in 1996?
Provide a succinct answer. 0.54. What is the ratio of the Aid flow from UN agencies (US$) in Kenya in 1995 to that in 1996?
Offer a terse response. 2.6. What is the ratio of the Aid flow from UN agencies (US$) of Macedonia in 1995 to that in 1996?
Ensure brevity in your answer.  0.17. What is the ratio of the Aid flow from UN agencies (US$) in Mauritania in 1995 to that in 1996?
Offer a terse response. 1.2. What is the ratio of the Aid flow from UN agencies (US$) of Europe(developing only) in 1995 to that in 1997?
Give a very brief answer. 0.38. What is the ratio of the Aid flow from UN agencies (US$) in Kenya in 1995 to that in 1997?
Ensure brevity in your answer.  0.53. What is the ratio of the Aid flow from UN agencies (US$) of Mauritania in 1995 to that in 1997?
Offer a very short reply. 0.81. What is the ratio of the Aid flow from UN agencies (US$) of Europe(developing only) in 1995 to that in 1998?
Ensure brevity in your answer.  0.34. What is the ratio of the Aid flow from UN agencies (US$) in Kenya in 1995 to that in 1998?
Ensure brevity in your answer.  0.44. What is the ratio of the Aid flow from UN agencies (US$) in Macedonia in 1995 to that in 1998?
Give a very brief answer. 0.18. What is the ratio of the Aid flow from UN agencies (US$) of Mauritania in 1995 to that in 1998?
Provide a succinct answer. 2.03. What is the ratio of the Aid flow from UN agencies (US$) in Europe(developing only) in 1995 to that in 1999?
Give a very brief answer. 0.33. What is the ratio of the Aid flow from UN agencies (US$) of Kenya in 1995 to that in 1999?
Keep it short and to the point. 0.64. What is the ratio of the Aid flow from UN agencies (US$) of Macedonia in 1995 to that in 1999?
Ensure brevity in your answer.  0.05. What is the ratio of the Aid flow from UN agencies (US$) of Mauritania in 1995 to that in 1999?
Keep it short and to the point. 1.25. What is the ratio of the Aid flow from UN agencies (US$) of Europe(developing only) in 1995 to that in 2000?
Offer a very short reply. 0.57. What is the ratio of the Aid flow from UN agencies (US$) of Kenya in 1995 to that in 2000?
Your response must be concise. 0.71. What is the ratio of the Aid flow from UN agencies (US$) in Macedonia in 1995 to that in 2000?
Give a very brief answer. 0.05. What is the ratio of the Aid flow from UN agencies (US$) of Mauritania in 1995 to that in 2000?
Provide a short and direct response. 1.65. What is the ratio of the Aid flow from UN agencies (US$) of Europe(developing only) in 1995 to that in 2001?
Provide a succinct answer. 0.58. What is the ratio of the Aid flow from UN agencies (US$) in Kenya in 1995 to that in 2001?
Your answer should be compact. 0.67. What is the ratio of the Aid flow from UN agencies (US$) in Macedonia in 1995 to that in 2001?
Give a very brief answer. 0.08. What is the ratio of the Aid flow from UN agencies (US$) of Mauritania in 1995 to that in 2001?
Your answer should be compact. 3.8. What is the ratio of the Aid flow from UN agencies (US$) in Europe(developing only) in 1996 to that in 1997?
Make the answer very short. 0.7. What is the ratio of the Aid flow from UN agencies (US$) in Kenya in 1996 to that in 1997?
Provide a short and direct response. 0.2. What is the ratio of the Aid flow from UN agencies (US$) in Macedonia in 1996 to that in 1997?
Ensure brevity in your answer.  1.93. What is the ratio of the Aid flow from UN agencies (US$) in Mauritania in 1996 to that in 1997?
Make the answer very short. 0.68. What is the ratio of the Aid flow from UN agencies (US$) in Europe(developing only) in 1996 to that in 1998?
Your answer should be compact. 0.63. What is the ratio of the Aid flow from UN agencies (US$) in Kenya in 1996 to that in 1998?
Keep it short and to the point. 0.17. What is the ratio of the Aid flow from UN agencies (US$) in Macedonia in 1996 to that in 1998?
Ensure brevity in your answer.  1.04. What is the ratio of the Aid flow from UN agencies (US$) in Mauritania in 1996 to that in 1998?
Offer a terse response. 1.7. What is the ratio of the Aid flow from UN agencies (US$) in Europe(developing only) in 1996 to that in 1999?
Ensure brevity in your answer.  0.61. What is the ratio of the Aid flow from UN agencies (US$) of Kenya in 1996 to that in 1999?
Your response must be concise. 0.25. What is the ratio of the Aid flow from UN agencies (US$) in Macedonia in 1996 to that in 1999?
Give a very brief answer. 0.29. What is the ratio of the Aid flow from UN agencies (US$) of Mauritania in 1996 to that in 1999?
Provide a short and direct response. 1.05. What is the ratio of the Aid flow from UN agencies (US$) in Europe(developing only) in 1996 to that in 2000?
Ensure brevity in your answer.  1.05. What is the ratio of the Aid flow from UN agencies (US$) of Kenya in 1996 to that in 2000?
Your response must be concise. 0.27. What is the ratio of the Aid flow from UN agencies (US$) in Macedonia in 1996 to that in 2000?
Offer a terse response. 0.27. What is the ratio of the Aid flow from UN agencies (US$) of Mauritania in 1996 to that in 2000?
Ensure brevity in your answer.  1.38. What is the ratio of the Aid flow from UN agencies (US$) of Europe(developing only) in 1996 to that in 2001?
Offer a terse response. 1.07. What is the ratio of the Aid flow from UN agencies (US$) in Kenya in 1996 to that in 2001?
Your answer should be compact. 0.26. What is the ratio of the Aid flow from UN agencies (US$) in Macedonia in 1996 to that in 2001?
Give a very brief answer. 0.48. What is the ratio of the Aid flow from UN agencies (US$) in Mauritania in 1996 to that in 2001?
Offer a very short reply. 3.17. What is the ratio of the Aid flow from UN agencies (US$) of Europe(developing only) in 1997 to that in 1998?
Make the answer very short. 0.9. What is the ratio of the Aid flow from UN agencies (US$) of Kenya in 1997 to that in 1998?
Your response must be concise. 0.82. What is the ratio of the Aid flow from UN agencies (US$) of Macedonia in 1997 to that in 1998?
Make the answer very short. 0.54. What is the ratio of the Aid flow from UN agencies (US$) of Mauritania in 1997 to that in 1998?
Your response must be concise. 2.5. What is the ratio of the Aid flow from UN agencies (US$) of Kenya in 1997 to that in 1999?
Provide a succinct answer. 1.21. What is the ratio of the Aid flow from UN agencies (US$) of Macedonia in 1997 to that in 1999?
Your answer should be very brief. 0.15. What is the ratio of the Aid flow from UN agencies (US$) in Mauritania in 1997 to that in 1999?
Ensure brevity in your answer.  1.55. What is the ratio of the Aid flow from UN agencies (US$) of Europe(developing only) in 1997 to that in 2000?
Ensure brevity in your answer.  1.51. What is the ratio of the Aid flow from UN agencies (US$) in Kenya in 1997 to that in 2000?
Offer a terse response. 1.34. What is the ratio of the Aid flow from UN agencies (US$) of Macedonia in 1997 to that in 2000?
Keep it short and to the point. 0.14. What is the ratio of the Aid flow from UN agencies (US$) in Mauritania in 1997 to that in 2000?
Make the answer very short. 2.03. What is the ratio of the Aid flow from UN agencies (US$) of Europe(developing only) in 1997 to that in 2001?
Offer a very short reply. 1.53. What is the ratio of the Aid flow from UN agencies (US$) in Kenya in 1997 to that in 2001?
Your answer should be very brief. 1.26. What is the ratio of the Aid flow from UN agencies (US$) of Macedonia in 1997 to that in 2001?
Offer a terse response. 0.25. What is the ratio of the Aid flow from UN agencies (US$) in Mauritania in 1997 to that in 2001?
Provide a short and direct response. 4.67. What is the ratio of the Aid flow from UN agencies (US$) of Europe(developing only) in 1998 to that in 1999?
Your answer should be very brief. 0.98. What is the ratio of the Aid flow from UN agencies (US$) of Kenya in 1998 to that in 1999?
Give a very brief answer. 1.48. What is the ratio of the Aid flow from UN agencies (US$) in Macedonia in 1998 to that in 1999?
Keep it short and to the point. 0.28. What is the ratio of the Aid flow from UN agencies (US$) in Mauritania in 1998 to that in 1999?
Provide a short and direct response. 0.62. What is the ratio of the Aid flow from UN agencies (US$) in Europe(developing only) in 1998 to that in 2000?
Make the answer very short. 1.68. What is the ratio of the Aid flow from UN agencies (US$) in Kenya in 1998 to that in 2000?
Give a very brief answer. 1.63. What is the ratio of the Aid flow from UN agencies (US$) in Macedonia in 1998 to that in 2000?
Your answer should be compact. 0.26. What is the ratio of the Aid flow from UN agencies (US$) in Mauritania in 1998 to that in 2000?
Your response must be concise. 0.81. What is the ratio of the Aid flow from UN agencies (US$) in Europe(developing only) in 1998 to that in 2001?
Offer a very short reply. 1.7. What is the ratio of the Aid flow from UN agencies (US$) in Kenya in 1998 to that in 2001?
Offer a very short reply. 1.54. What is the ratio of the Aid flow from UN agencies (US$) of Macedonia in 1998 to that in 2001?
Offer a very short reply. 0.46. What is the ratio of the Aid flow from UN agencies (US$) in Mauritania in 1998 to that in 2001?
Offer a very short reply. 1.87. What is the ratio of the Aid flow from UN agencies (US$) in Europe(developing only) in 1999 to that in 2000?
Your answer should be very brief. 1.72. What is the ratio of the Aid flow from UN agencies (US$) in Kenya in 1999 to that in 2000?
Offer a terse response. 1.1. What is the ratio of the Aid flow from UN agencies (US$) in Macedonia in 1999 to that in 2000?
Your answer should be very brief. 0.93. What is the ratio of the Aid flow from UN agencies (US$) of Mauritania in 1999 to that in 2000?
Provide a short and direct response. 1.31. What is the ratio of the Aid flow from UN agencies (US$) of Europe(developing only) in 1999 to that in 2001?
Make the answer very short. 1.74. What is the ratio of the Aid flow from UN agencies (US$) of Kenya in 1999 to that in 2001?
Your answer should be very brief. 1.04. What is the ratio of the Aid flow from UN agencies (US$) in Macedonia in 1999 to that in 2001?
Your answer should be compact. 1.62. What is the ratio of the Aid flow from UN agencies (US$) of Mauritania in 1999 to that in 2001?
Ensure brevity in your answer.  3.02. What is the ratio of the Aid flow from UN agencies (US$) of Europe(developing only) in 2000 to that in 2001?
Offer a very short reply. 1.01. What is the ratio of the Aid flow from UN agencies (US$) of Kenya in 2000 to that in 2001?
Give a very brief answer. 0.94. What is the ratio of the Aid flow from UN agencies (US$) in Macedonia in 2000 to that in 2001?
Provide a succinct answer. 1.75. What is the ratio of the Aid flow from UN agencies (US$) of Mauritania in 2000 to that in 2001?
Give a very brief answer. 2.3. What is the difference between the highest and the second highest Aid flow from UN agencies (US$) of Europe(developing only)?
Your answer should be compact. 7.70e+05. What is the difference between the highest and the second highest Aid flow from UN agencies (US$) of Kenya?
Offer a terse response. 1.42e+06. What is the difference between the highest and the second highest Aid flow from UN agencies (US$) of Macedonia?
Provide a short and direct response. 8.00e+04. What is the difference between the highest and the second highest Aid flow from UN agencies (US$) in Mauritania?
Ensure brevity in your answer.  7.30e+05. What is the difference between the highest and the lowest Aid flow from UN agencies (US$) in Europe(developing only)?
Keep it short and to the point. 2.22e+07. What is the difference between the highest and the lowest Aid flow from UN agencies (US$) of Kenya?
Offer a terse response. 6.62e+06. What is the difference between the highest and the lowest Aid flow from UN agencies (US$) of Macedonia?
Your answer should be compact. 1.02e+06. What is the difference between the highest and the lowest Aid flow from UN agencies (US$) in Mauritania?
Offer a very short reply. 3.05e+06. 